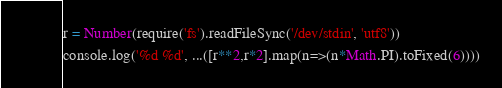Convert code to text. <code><loc_0><loc_0><loc_500><loc_500><_JavaScript_>r = Number(require('fs').readFileSync('/dev/stdin', 'utf8'))
console.log('%d %d', ...([r**2,r*2].map(n=>(n*Math.PI).toFixed(6))))
</code> 